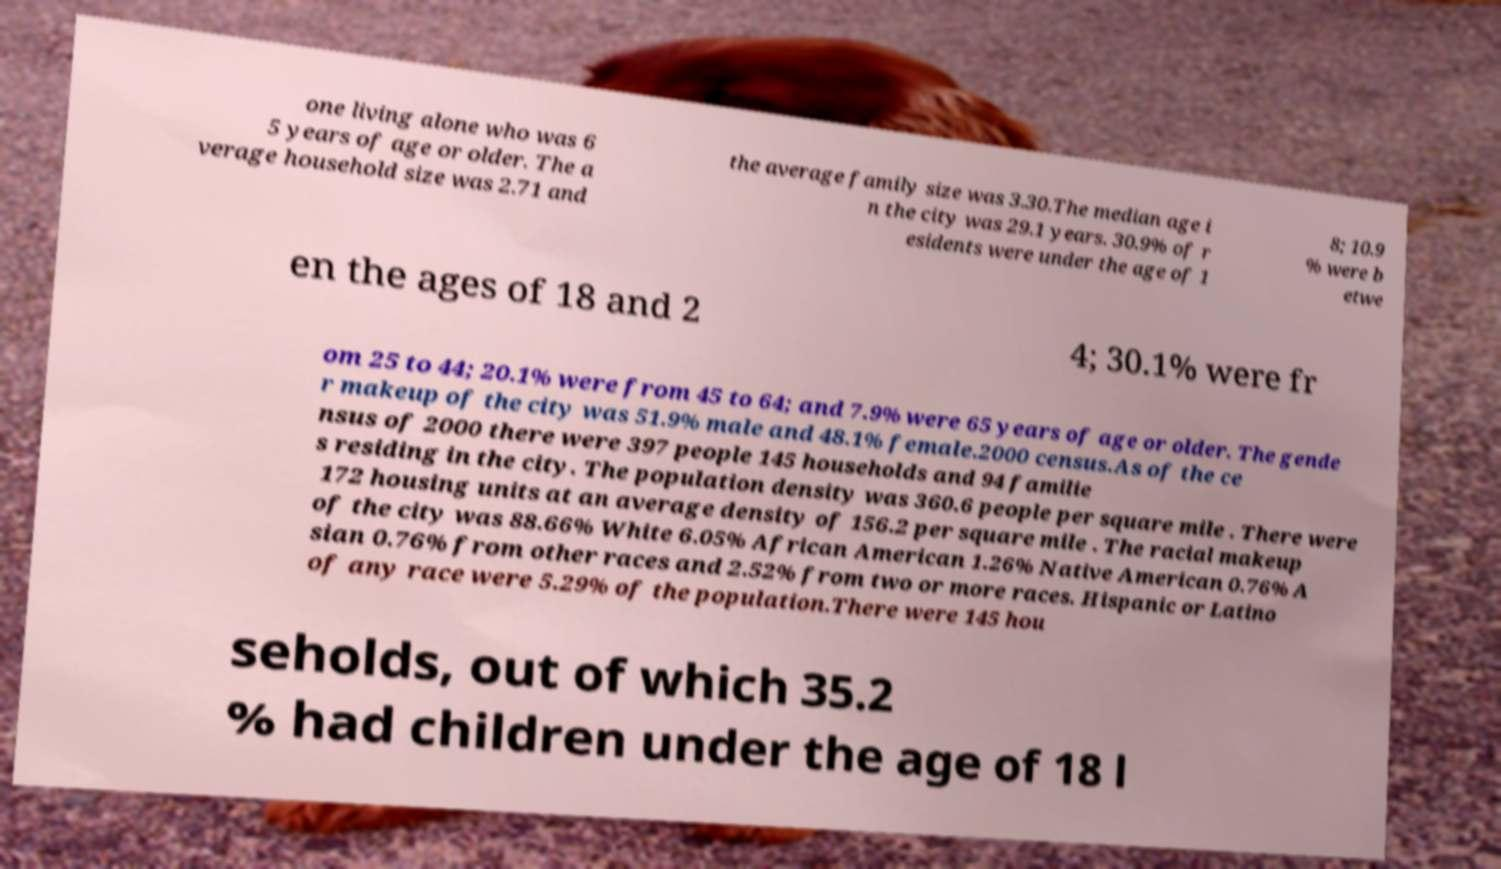Please identify and transcribe the text found in this image. one living alone who was 6 5 years of age or older. The a verage household size was 2.71 and the average family size was 3.30.The median age i n the city was 29.1 years. 30.9% of r esidents were under the age of 1 8; 10.9 % were b etwe en the ages of 18 and 2 4; 30.1% were fr om 25 to 44; 20.1% were from 45 to 64; and 7.9% were 65 years of age or older. The gende r makeup of the city was 51.9% male and 48.1% female.2000 census.As of the ce nsus of 2000 there were 397 people 145 households and 94 familie s residing in the city. The population density was 360.6 people per square mile . There were 172 housing units at an average density of 156.2 per square mile . The racial makeup of the city was 88.66% White 6.05% African American 1.26% Native American 0.76% A sian 0.76% from other races and 2.52% from two or more races. Hispanic or Latino of any race were 5.29% of the population.There were 145 hou seholds, out of which 35.2 % had children under the age of 18 l 